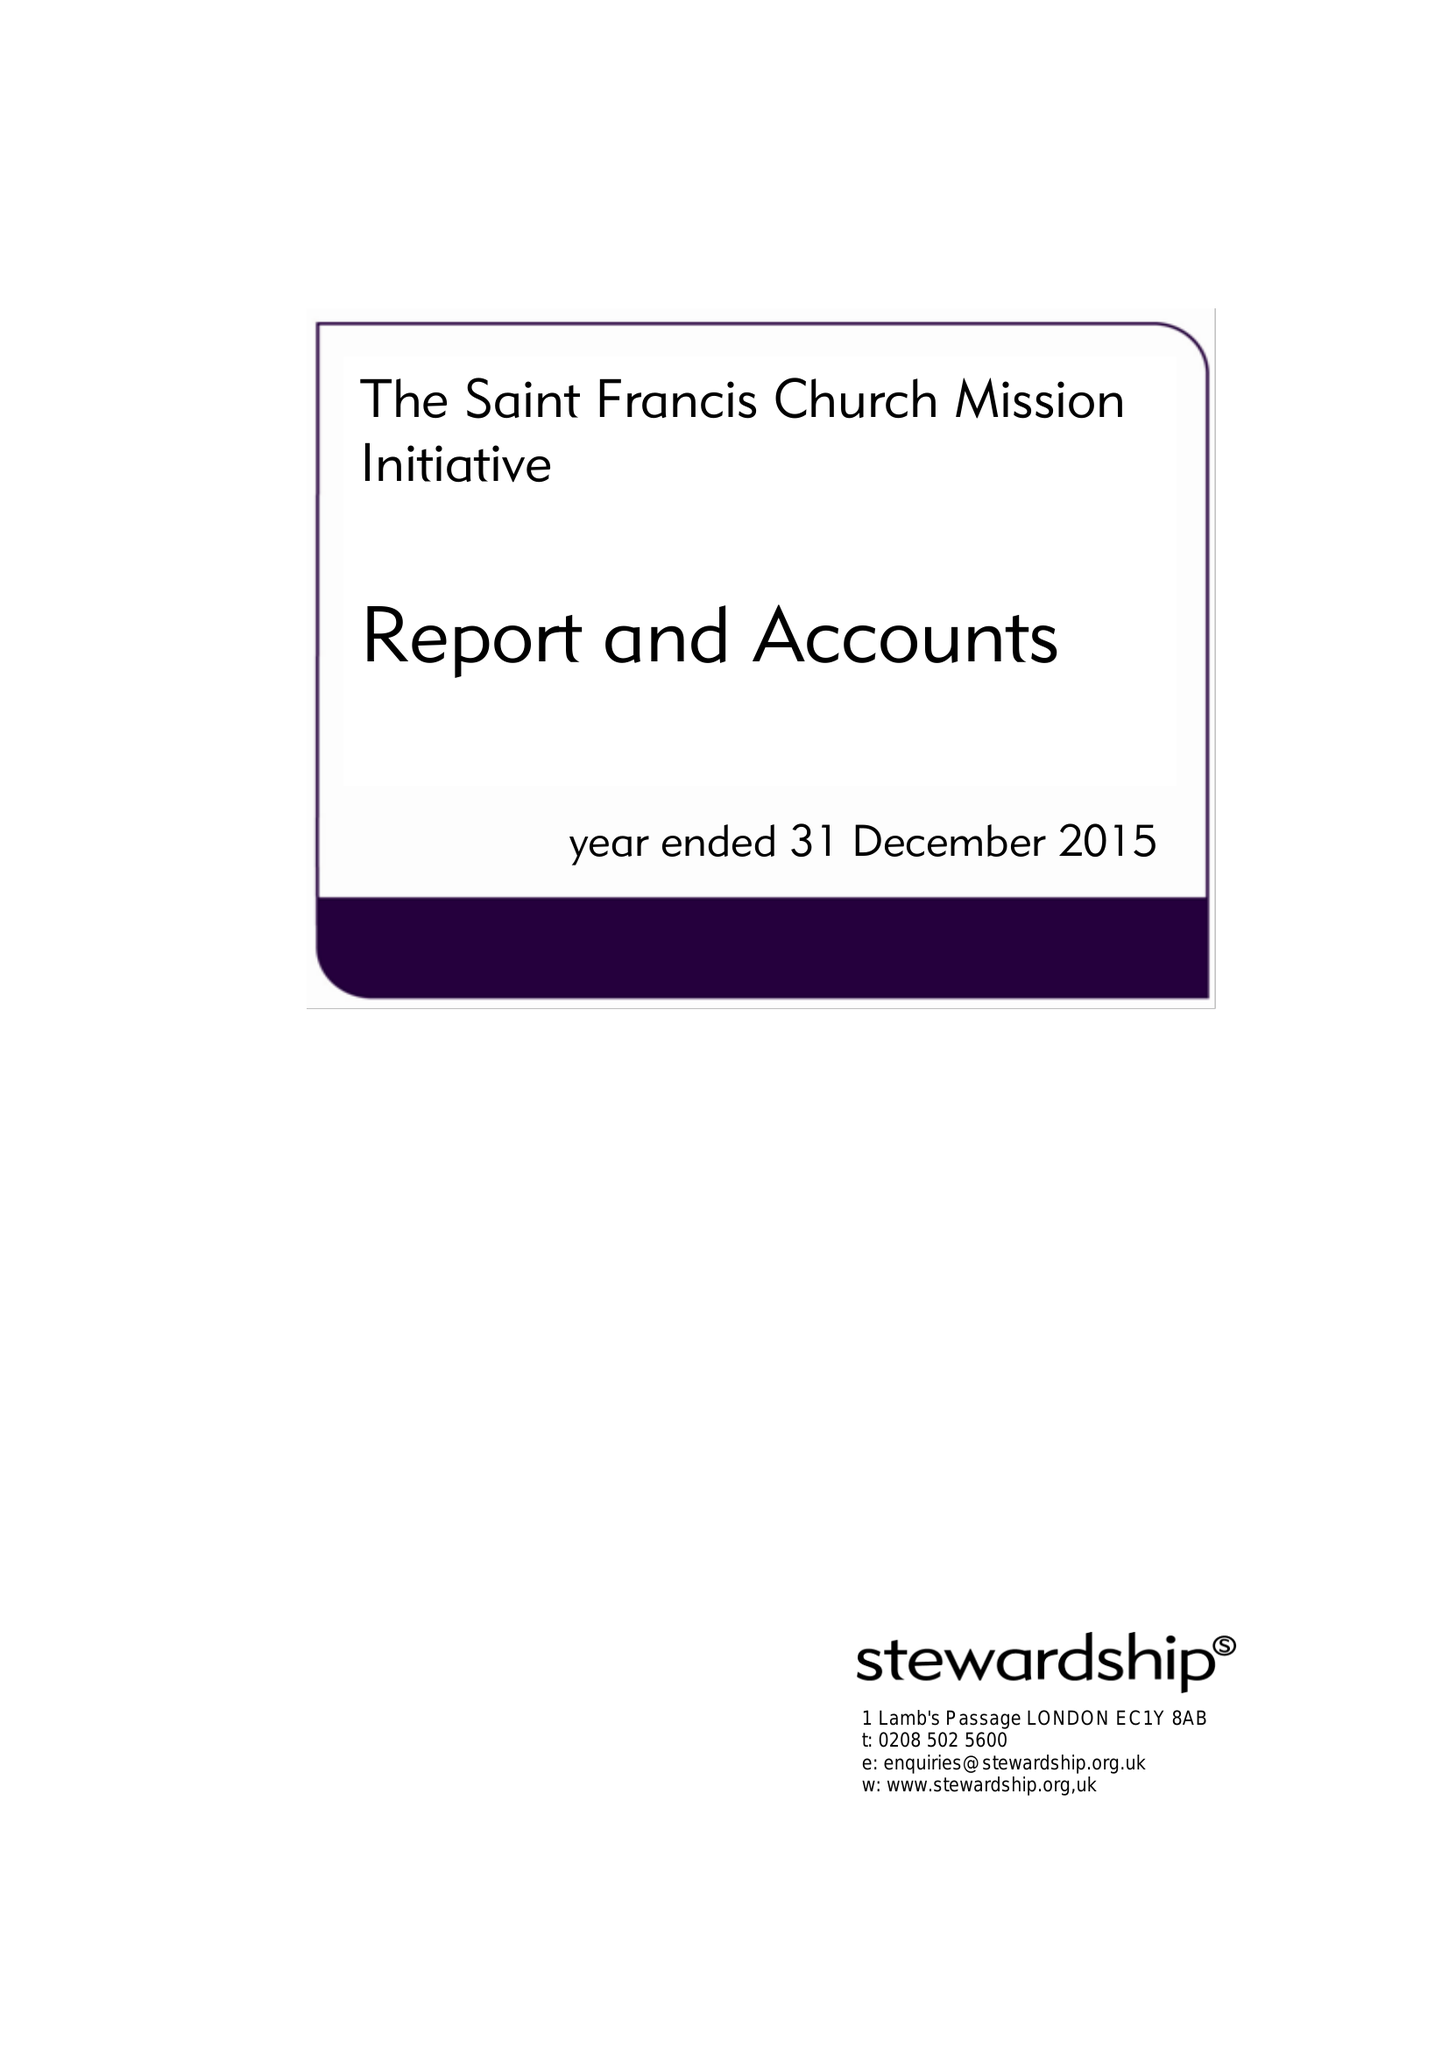What is the value for the income_annually_in_british_pounds?
Answer the question using a single word or phrase. 138679.00 